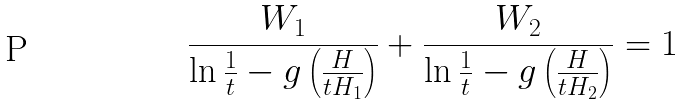<formula> <loc_0><loc_0><loc_500><loc_500>\frac { W _ { 1 } } { \ln \frac { 1 } { t } - g \left ( \frac { H } { t H _ { 1 } } \right ) } + \frac { W _ { 2 } } { \ln \frac { 1 } { t } - g \left ( \frac { H } { t H _ { 2 } } \right ) } = 1</formula> 